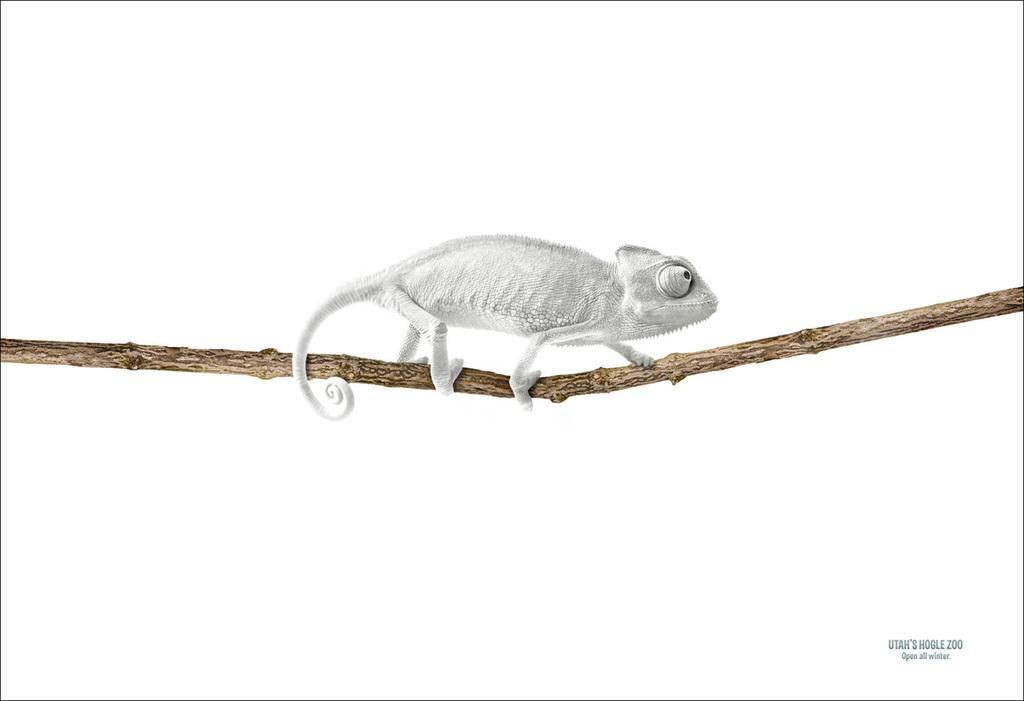Could you give a brief overview of what you see in this image? In the image there is a wooden stick and on the wooden stick there is a toy of some animal. 